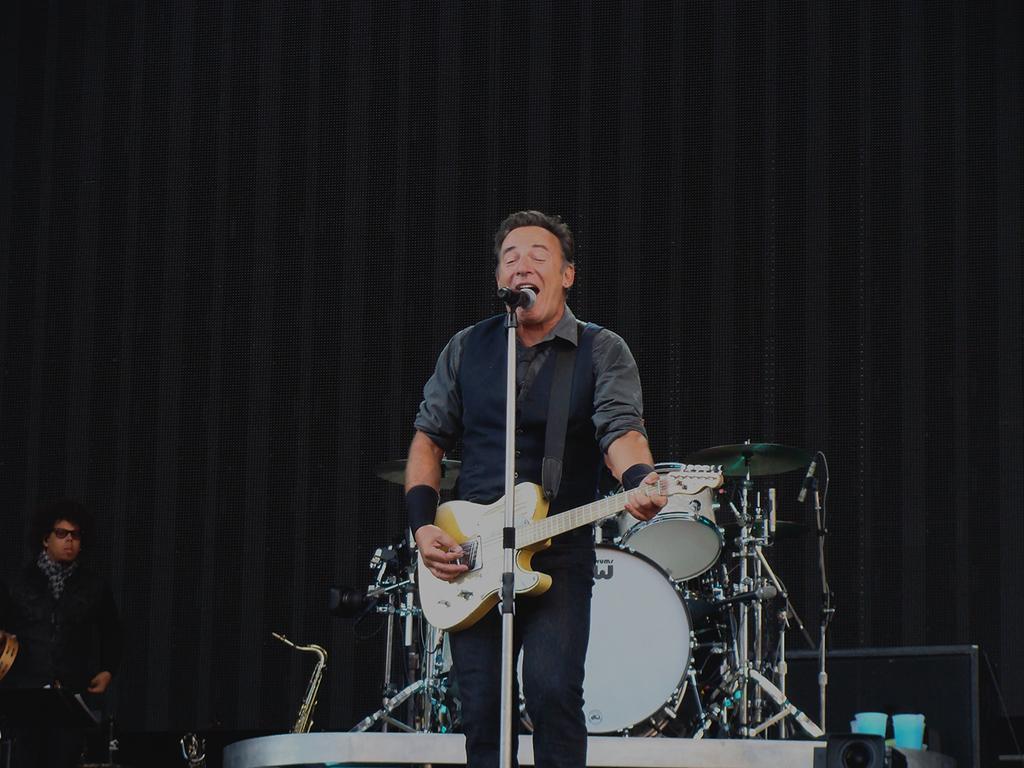In one or two sentences, can you explain what this image depicts? A man is singing with a mic in front of him while playing guitar. 